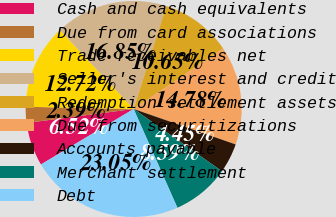Convert chart to OTSL. <chart><loc_0><loc_0><loc_500><loc_500><pie_chart><fcel>Cash and cash equivalents<fcel>Due from card associations<fcel>Trade receivables net<fcel>Seller's interest and credit<fcel>Redemption settlement assets<fcel>Due from securitizations<fcel>Accounts payable<fcel>Merchant settlement<fcel>Debt<nl><fcel>6.52%<fcel>2.39%<fcel>12.72%<fcel>16.85%<fcel>10.65%<fcel>14.78%<fcel>4.45%<fcel>8.59%<fcel>23.05%<nl></chart> 